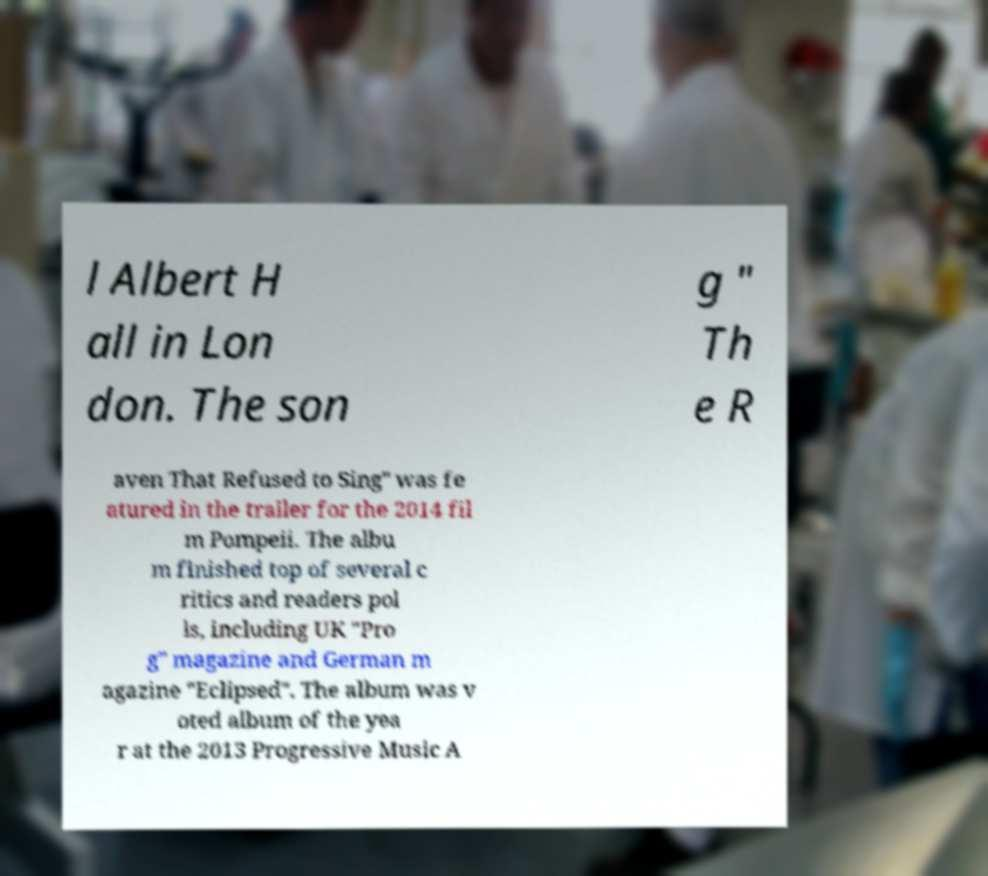Can you accurately transcribe the text from the provided image for me? l Albert H all in Lon don. The son g " Th e R aven That Refused to Sing" was fe atured in the trailer for the 2014 fil m Pompeii. The albu m finished top of several c ritics and readers pol ls, including UK "Pro g" magazine and German m agazine "Eclipsed". The album was v oted album of the yea r at the 2013 Progressive Music A 